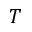<formula> <loc_0><loc_0><loc_500><loc_500>T</formula> 